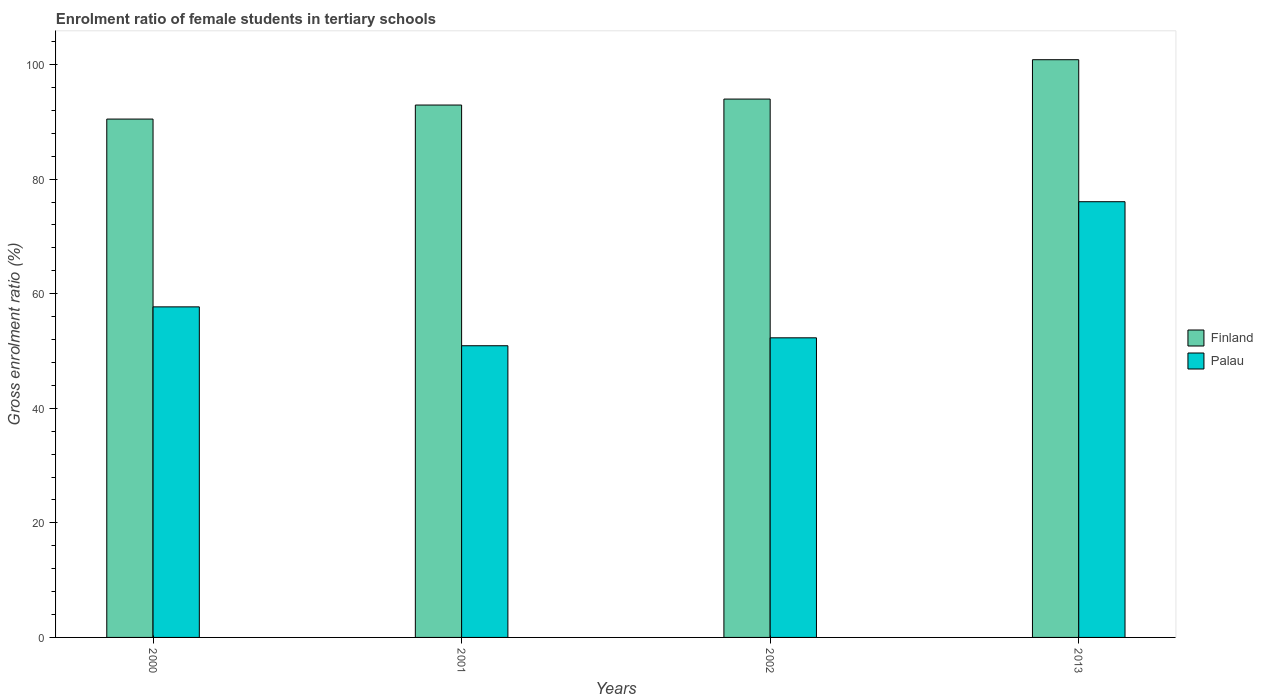How many groups of bars are there?
Offer a terse response. 4. Are the number of bars per tick equal to the number of legend labels?
Your response must be concise. Yes. Are the number of bars on each tick of the X-axis equal?
Your response must be concise. Yes. What is the label of the 4th group of bars from the left?
Your answer should be compact. 2013. In how many cases, is the number of bars for a given year not equal to the number of legend labels?
Your answer should be compact. 0. What is the enrolment ratio of female students in tertiary schools in Palau in 2002?
Offer a very short reply. 52.3. Across all years, what is the maximum enrolment ratio of female students in tertiary schools in Palau?
Provide a succinct answer. 76.06. Across all years, what is the minimum enrolment ratio of female students in tertiary schools in Finland?
Provide a succinct answer. 90.49. In which year was the enrolment ratio of female students in tertiary schools in Palau maximum?
Keep it short and to the point. 2013. What is the total enrolment ratio of female students in tertiary schools in Finland in the graph?
Your answer should be compact. 378.25. What is the difference between the enrolment ratio of female students in tertiary schools in Finland in 2000 and that in 2002?
Offer a very short reply. -3.49. What is the difference between the enrolment ratio of female students in tertiary schools in Palau in 2001 and the enrolment ratio of female students in tertiary schools in Finland in 2013?
Provide a short and direct response. -49.93. What is the average enrolment ratio of female students in tertiary schools in Finland per year?
Make the answer very short. 94.56. In the year 2013, what is the difference between the enrolment ratio of female students in tertiary schools in Finland and enrolment ratio of female students in tertiary schools in Palau?
Offer a very short reply. 24.79. In how many years, is the enrolment ratio of female students in tertiary schools in Palau greater than 24 %?
Your response must be concise. 4. What is the ratio of the enrolment ratio of female students in tertiary schools in Finland in 2000 to that in 2001?
Make the answer very short. 0.97. Is the difference between the enrolment ratio of female students in tertiary schools in Finland in 2000 and 2001 greater than the difference between the enrolment ratio of female students in tertiary schools in Palau in 2000 and 2001?
Offer a very short reply. No. What is the difference between the highest and the second highest enrolment ratio of female students in tertiary schools in Palau?
Your answer should be compact. 18.36. What is the difference between the highest and the lowest enrolment ratio of female students in tertiary schools in Palau?
Ensure brevity in your answer.  25.14. Is the sum of the enrolment ratio of female students in tertiary schools in Palau in 2001 and 2002 greater than the maximum enrolment ratio of female students in tertiary schools in Finland across all years?
Provide a succinct answer. Yes. What does the 2nd bar from the left in 2013 represents?
Offer a very short reply. Palau. What does the 2nd bar from the right in 2000 represents?
Your answer should be compact. Finland. How many bars are there?
Your answer should be compact. 8. How many legend labels are there?
Keep it short and to the point. 2. What is the title of the graph?
Offer a very short reply. Enrolment ratio of female students in tertiary schools. Does "Ethiopia" appear as one of the legend labels in the graph?
Make the answer very short. No. What is the label or title of the Y-axis?
Provide a succinct answer. Gross enrolment ratio (%). What is the Gross enrolment ratio (%) in Finland in 2000?
Offer a terse response. 90.49. What is the Gross enrolment ratio (%) of Palau in 2000?
Your answer should be very brief. 57.7. What is the Gross enrolment ratio (%) in Finland in 2001?
Make the answer very short. 92.93. What is the Gross enrolment ratio (%) of Palau in 2001?
Provide a short and direct response. 50.92. What is the Gross enrolment ratio (%) of Finland in 2002?
Offer a very short reply. 93.98. What is the Gross enrolment ratio (%) in Palau in 2002?
Ensure brevity in your answer.  52.3. What is the Gross enrolment ratio (%) of Finland in 2013?
Provide a succinct answer. 100.85. What is the Gross enrolment ratio (%) in Palau in 2013?
Ensure brevity in your answer.  76.06. Across all years, what is the maximum Gross enrolment ratio (%) of Finland?
Your response must be concise. 100.85. Across all years, what is the maximum Gross enrolment ratio (%) in Palau?
Make the answer very short. 76.06. Across all years, what is the minimum Gross enrolment ratio (%) in Finland?
Your response must be concise. 90.49. Across all years, what is the minimum Gross enrolment ratio (%) of Palau?
Provide a succinct answer. 50.92. What is the total Gross enrolment ratio (%) of Finland in the graph?
Your answer should be very brief. 378.25. What is the total Gross enrolment ratio (%) of Palau in the graph?
Offer a terse response. 236.98. What is the difference between the Gross enrolment ratio (%) in Finland in 2000 and that in 2001?
Your answer should be compact. -2.45. What is the difference between the Gross enrolment ratio (%) of Palau in 2000 and that in 2001?
Ensure brevity in your answer.  6.78. What is the difference between the Gross enrolment ratio (%) of Finland in 2000 and that in 2002?
Keep it short and to the point. -3.49. What is the difference between the Gross enrolment ratio (%) of Palau in 2000 and that in 2002?
Give a very brief answer. 5.4. What is the difference between the Gross enrolment ratio (%) in Finland in 2000 and that in 2013?
Make the answer very short. -10.36. What is the difference between the Gross enrolment ratio (%) of Palau in 2000 and that in 2013?
Keep it short and to the point. -18.36. What is the difference between the Gross enrolment ratio (%) of Finland in 2001 and that in 2002?
Give a very brief answer. -1.04. What is the difference between the Gross enrolment ratio (%) in Palau in 2001 and that in 2002?
Offer a terse response. -1.38. What is the difference between the Gross enrolment ratio (%) of Finland in 2001 and that in 2013?
Keep it short and to the point. -7.91. What is the difference between the Gross enrolment ratio (%) in Palau in 2001 and that in 2013?
Give a very brief answer. -25.14. What is the difference between the Gross enrolment ratio (%) in Finland in 2002 and that in 2013?
Offer a terse response. -6.87. What is the difference between the Gross enrolment ratio (%) in Palau in 2002 and that in 2013?
Your response must be concise. -23.76. What is the difference between the Gross enrolment ratio (%) in Finland in 2000 and the Gross enrolment ratio (%) in Palau in 2001?
Offer a very short reply. 39.57. What is the difference between the Gross enrolment ratio (%) in Finland in 2000 and the Gross enrolment ratio (%) in Palau in 2002?
Give a very brief answer. 38.19. What is the difference between the Gross enrolment ratio (%) of Finland in 2000 and the Gross enrolment ratio (%) of Palau in 2013?
Make the answer very short. 14.42. What is the difference between the Gross enrolment ratio (%) in Finland in 2001 and the Gross enrolment ratio (%) in Palau in 2002?
Ensure brevity in your answer.  40.63. What is the difference between the Gross enrolment ratio (%) in Finland in 2001 and the Gross enrolment ratio (%) in Palau in 2013?
Offer a very short reply. 16.87. What is the difference between the Gross enrolment ratio (%) in Finland in 2002 and the Gross enrolment ratio (%) in Palau in 2013?
Your answer should be very brief. 17.92. What is the average Gross enrolment ratio (%) in Finland per year?
Your answer should be very brief. 94.56. What is the average Gross enrolment ratio (%) in Palau per year?
Provide a short and direct response. 59.25. In the year 2000, what is the difference between the Gross enrolment ratio (%) of Finland and Gross enrolment ratio (%) of Palau?
Offer a very short reply. 32.78. In the year 2001, what is the difference between the Gross enrolment ratio (%) of Finland and Gross enrolment ratio (%) of Palau?
Offer a very short reply. 42.02. In the year 2002, what is the difference between the Gross enrolment ratio (%) of Finland and Gross enrolment ratio (%) of Palau?
Make the answer very short. 41.68. In the year 2013, what is the difference between the Gross enrolment ratio (%) in Finland and Gross enrolment ratio (%) in Palau?
Give a very brief answer. 24.79. What is the ratio of the Gross enrolment ratio (%) in Finland in 2000 to that in 2001?
Your response must be concise. 0.97. What is the ratio of the Gross enrolment ratio (%) of Palau in 2000 to that in 2001?
Provide a succinct answer. 1.13. What is the ratio of the Gross enrolment ratio (%) of Finland in 2000 to that in 2002?
Make the answer very short. 0.96. What is the ratio of the Gross enrolment ratio (%) of Palau in 2000 to that in 2002?
Ensure brevity in your answer.  1.1. What is the ratio of the Gross enrolment ratio (%) of Finland in 2000 to that in 2013?
Your answer should be compact. 0.9. What is the ratio of the Gross enrolment ratio (%) of Palau in 2000 to that in 2013?
Offer a very short reply. 0.76. What is the ratio of the Gross enrolment ratio (%) of Finland in 2001 to that in 2002?
Make the answer very short. 0.99. What is the ratio of the Gross enrolment ratio (%) in Palau in 2001 to that in 2002?
Make the answer very short. 0.97. What is the ratio of the Gross enrolment ratio (%) of Finland in 2001 to that in 2013?
Offer a very short reply. 0.92. What is the ratio of the Gross enrolment ratio (%) of Palau in 2001 to that in 2013?
Offer a terse response. 0.67. What is the ratio of the Gross enrolment ratio (%) in Finland in 2002 to that in 2013?
Provide a succinct answer. 0.93. What is the ratio of the Gross enrolment ratio (%) of Palau in 2002 to that in 2013?
Provide a succinct answer. 0.69. What is the difference between the highest and the second highest Gross enrolment ratio (%) in Finland?
Make the answer very short. 6.87. What is the difference between the highest and the second highest Gross enrolment ratio (%) in Palau?
Keep it short and to the point. 18.36. What is the difference between the highest and the lowest Gross enrolment ratio (%) of Finland?
Offer a terse response. 10.36. What is the difference between the highest and the lowest Gross enrolment ratio (%) of Palau?
Ensure brevity in your answer.  25.14. 